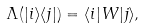Convert formula to latex. <formula><loc_0><loc_0><loc_500><loc_500>\Lambda ( | i \rangle \langle j | ) = \langle i | W | j \rangle ,</formula> 